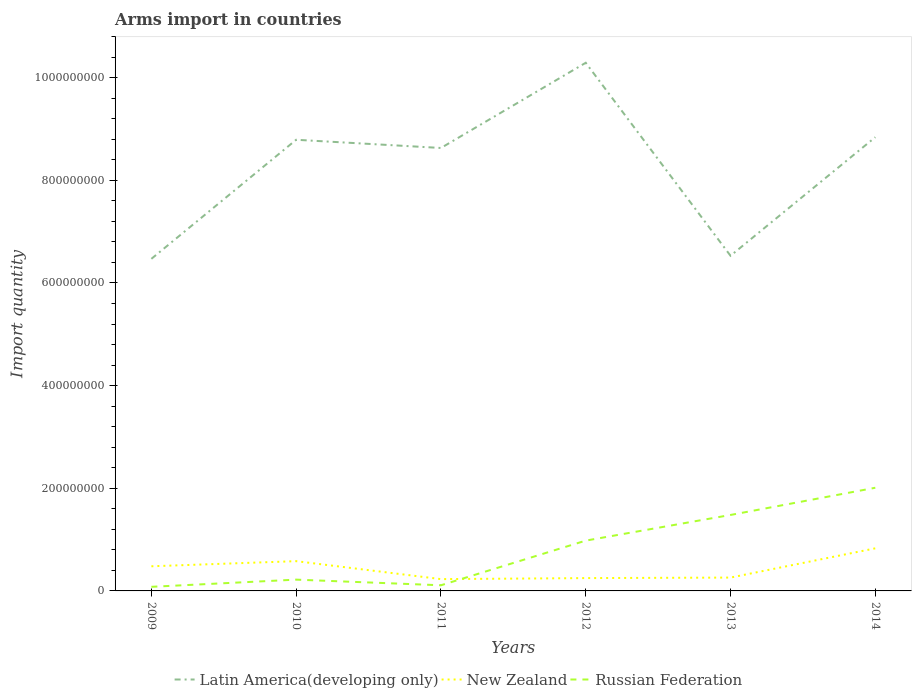How many different coloured lines are there?
Provide a succinct answer. 3. Does the line corresponding to Russian Federation intersect with the line corresponding to New Zealand?
Give a very brief answer. Yes. Across all years, what is the maximum total arms import in Russian Federation?
Offer a very short reply. 8.00e+06. What is the total total arms import in Russian Federation in the graph?
Offer a very short reply. -7.60e+07. What is the difference between the highest and the second highest total arms import in New Zealand?
Offer a terse response. 6.00e+07. How many lines are there?
Keep it short and to the point. 3. How many years are there in the graph?
Your response must be concise. 6. What is the difference between two consecutive major ticks on the Y-axis?
Your answer should be very brief. 2.00e+08. Are the values on the major ticks of Y-axis written in scientific E-notation?
Provide a succinct answer. No. Does the graph contain any zero values?
Provide a short and direct response. No. Does the graph contain grids?
Ensure brevity in your answer.  No. Where does the legend appear in the graph?
Your answer should be very brief. Bottom center. How many legend labels are there?
Provide a succinct answer. 3. How are the legend labels stacked?
Provide a succinct answer. Horizontal. What is the title of the graph?
Ensure brevity in your answer.  Arms import in countries. Does "Panama" appear as one of the legend labels in the graph?
Offer a very short reply. No. What is the label or title of the Y-axis?
Offer a very short reply. Import quantity. What is the Import quantity of Latin America(developing only) in 2009?
Make the answer very short. 6.47e+08. What is the Import quantity of New Zealand in 2009?
Your answer should be very brief. 4.80e+07. What is the Import quantity of Russian Federation in 2009?
Make the answer very short. 8.00e+06. What is the Import quantity in Latin America(developing only) in 2010?
Offer a terse response. 8.79e+08. What is the Import quantity in New Zealand in 2010?
Make the answer very short. 5.80e+07. What is the Import quantity in Russian Federation in 2010?
Your answer should be very brief. 2.20e+07. What is the Import quantity of Latin America(developing only) in 2011?
Ensure brevity in your answer.  8.63e+08. What is the Import quantity of New Zealand in 2011?
Provide a short and direct response. 2.30e+07. What is the Import quantity of Russian Federation in 2011?
Provide a short and direct response. 1.10e+07. What is the Import quantity of Latin America(developing only) in 2012?
Provide a succinct answer. 1.03e+09. What is the Import quantity in New Zealand in 2012?
Keep it short and to the point. 2.50e+07. What is the Import quantity in Russian Federation in 2012?
Offer a terse response. 9.80e+07. What is the Import quantity of Latin America(developing only) in 2013?
Make the answer very short. 6.53e+08. What is the Import quantity of New Zealand in 2013?
Give a very brief answer. 2.60e+07. What is the Import quantity in Russian Federation in 2013?
Your response must be concise. 1.48e+08. What is the Import quantity of Latin America(developing only) in 2014?
Keep it short and to the point. 8.84e+08. What is the Import quantity of New Zealand in 2014?
Provide a succinct answer. 8.30e+07. What is the Import quantity of Russian Federation in 2014?
Give a very brief answer. 2.01e+08. Across all years, what is the maximum Import quantity in Latin America(developing only)?
Make the answer very short. 1.03e+09. Across all years, what is the maximum Import quantity of New Zealand?
Keep it short and to the point. 8.30e+07. Across all years, what is the maximum Import quantity in Russian Federation?
Your response must be concise. 2.01e+08. Across all years, what is the minimum Import quantity of Latin America(developing only)?
Make the answer very short. 6.47e+08. Across all years, what is the minimum Import quantity of New Zealand?
Ensure brevity in your answer.  2.30e+07. Across all years, what is the minimum Import quantity in Russian Federation?
Ensure brevity in your answer.  8.00e+06. What is the total Import quantity of Latin America(developing only) in the graph?
Make the answer very short. 4.96e+09. What is the total Import quantity in New Zealand in the graph?
Offer a very short reply. 2.63e+08. What is the total Import quantity in Russian Federation in the graph?
Your answer should be very brief. 4.88e+08. What is the difference between the Import quantity of Latin America(developing only) in 2009 and that in 2010?
Your answer should be very brief. -2.32e+08. What is the difference between the Import quantity in New Zealand in 2009 and that in 2010?
Your answer should be very brief. -1.00e+07. What is the difference between the Import quantity in Russian Federation in 2009 and that in 2010?
Provide a succinct answer. -1.40e+07. What is the difference between the Import quantity in Latin America(developing only) in 2009 and that in 2011?
Offer a terse response. -2.16e+08. What is the difference between the Import quantity of New Zealand in 2009 and that in 2011?
Make the answer very short. 2.50e+07. What is the difference between the Import quantity in Russian Federation in 2009 and that in 2011?
Offer a very short reply. -3.00e+06. What is the difference between the Import quantity in Latin America(developing only) in 2009 and that in 2012?
Offer a very short reply. -3.82e+08. What is the difference between the Import quantity in New Zealand in 2009 and that in 2012?
Give a very brief answer. 2.30e+07. What is the difference between the Import quantity of Russian Federation in 2009 and that in 2012?
Offer a terse response. -9.00e+07. What is the difference between the Import quantity of Latin America(developing only) in 2009 and that in 2013?
Provide a short and direct response. -6.00e+06. What is the difference between the Import quantity of New Zealand in 2009 and that in 2013?
Give a very brief answer. 2.20e+07. What is the difference between the Import quantity of Russian Federation in 2009 and that in 2013?
Your answer should be compact. -1.40e+08. What is the difference between the Import quantity of Latin America(developing only) in 2009 and that in 2014?
Offer a terse response. -2.37e+08. What is the difference between the Import quantity of New Zealand in 2009 and that in 2014?
Ensure brevity in your answer.  -3.50e+07. What is the difference between the Import quantity of Russian Federation in 2009 and that in 2014?
Keep it short and to the point. -1.93e+08. What is the difference between the Import quantity in Latin America(developing only) in 2010 and that in 2011?
Your answer should be very brief. 1.60e+07. What is the difference between the Import quantity in New Zealand in 2010 and that in 2011?
Ensure brevity in your answer.  3.50e+07. What is the difference between the Import quantity in Russian Federation in 2010 and that in 2011?
Provide a short and direct response. 1.10e+07. What is the difference between the Import quantity in Latin America(developing only) in 2010 and that in 2012?
Offer a terse response. -1.50e+08. What is the difference between the Import quantity in New Zealand in 2010 and that in 2012?
Your answer should be very brief. 3.30e+07. What is the difference between the Import quantity in Russian Federation in 2010 and that in 2012?
Offer a very short reply. -7.60e+07. What is the difference between the Import quantity in Latin America(developing only) in 2010 and that in 2013?
Keep it short and to the point. 2.26e+08. What is the difference between the Import quantity in New Zealand in 2010 and that in 2013?
Your answer should be compact. 3.20e+07. What is the difference between the Import quantity of Russian Federation in 2010 and that in 2013?
Make the answer very short. -1.26e+08. What is the difference between the Import quantity of Latin America(developing only) in 2010 and that in 2014?
Give a very brief answer. -5.00e+06. What is the difference between the Import quantity in New Zealand in 2010 and that in 2014?
Give a very brief answer. -2.50e+07. What is the difference between the Import quantity of Russian Federation in 2010 and that in 2014?
Offer a terse response. -1.79e+08. What is the difference between the Import quantity in Latin America(developing only) in 2011 and that in 2012?
Provide a short and direct response. -1.66e+08. What is the difference between the Import quantity in New Zealand in 2011 and that in 2012?
Ensure brevity in your answer.  -2.00e+06. What is the difference between the Import quantity in Russian Federation in 2011 and that in 2012?
Ensure brevity in your answer.  -8.70e+07. What is the difference between the Import quantity of Latin America(developing only) in 2011 and that in 2013?
Your answer should be very brief. 2.10e+08. What is the difference between the Import quantity in Russian Federation in 2011 and that in 2013?
Your answer should be compact. -1.37e+08. What is the difference between the Import quantity of Latin America(developing only) in 2011 and that in 2014?
Your answer should be compact. -2.10e+07. What is the difference between the Import quantity in New Zealand in 2011 and that in 2014?
Provide a short and direct response. -6.00e+07. What is the difference between the Import quantity in Russian Federation in 2011 and that in 2014?
Keep it short and to the point. -1.90e+08. What is the difference between the Import quantity in Latin America(developing only) in 2012 and that in 2013?
Give a very brief answer. 3.76e+08. What is the difference between the Import quantity in New Zealand in 2012 and that in 2013?
Ensure brevity in your answer.  -1.00e+06. What is the difference between the Import quantity in Russian Federation in 2012 and that in 2013?
Keep it short and to the point. -5.00e+07. What is the difference between the Import quantity in Latin America(developing only) in 2012 and that in 2014?
Your response must be concise. 1.45e+08. What is the difference between the Import quantity of New Zealand in 2012 and that in 2014?
Offer a terse response. -5.80e+07. What is the difference between the Import quantity in Russian Federation in 2012 and that in 2014?
Give a very brief answer. -1.03e+08. What is the difference between the Import quantity in Latin America(developing only) in 2013 and that in 2014?
Your answer should be very brief. -2.31e+08. What is the difference between the Import quantity in New Zealand in 2013 and that in 2014?
Offer a very short reply. -5.70e+07. What is the difference between the Import quantity of Russian Federation in 2013 and that in 2014?
Give a very brief answer. -5.30e+07. What is the difference between the Import quantity in Latin America(developing only) in 2009 and the Import quantity in New Zealand in 2010?
Provide a short and direct response. 5.89e+08. What is the difference between the Import quantity in Latin America(developing only) in 2009 and the Import quantity in Russian Federation in 2010?
Provide a short and direct response. 6.25e+08. What is the difference between the Import quantity in New Zealand in 2009 and the Import quantity in Russian Federation in 2010?
Provide a short and direct response. 2.60e+07. What is the difference between the Import quantity of Latin America(developing only) in 2009 and the Import quantity of New Zealand in 2011?
Keep it short and to the point. 6.24e+08. What is the difference between the Import quantity in Latin America(developing only) in 2009 and the Import quantity in Russian Federation in 2011?
Keep it short and to the point. 6.36e+08. What is the difference between the Import quantity in New Zealand in 2009 and the Import quantity in Russian Federation in 2011?
Ensure brevity in your answer.  3.70e+07. What is the difference between the Import quantity of Latin America(developing only) in 2009 and the Import quantity of New Zealand in 2012?
Provide a short and direct response. 6.22e+08. What is the difference between the Import quantity of Latin America(developing only) in 2009 and the Import quantity of Russian Federation in 2012?
Your answer should be compact. 5.49e+08. What is the difference between the Import quantity in New Zealand in 2009 and the Import quantity in Russian Federation in 2012?
Keep it short and to the point. -5.00e+07. What is the difference between the Import quantity in Latin America(developing only) in 2009 and the Import quantity in New Zealand in 2013?
Provide a succinct answer. 6.21e+08. What is the difference between the Import quantity in Latin America(developing only) in 2009 and the Import quantity in Russian Federation in 2013?
Make the answer very short. 4.99e+08. What is the difference between the Import quantity in New Zealand in 2009 and the Import quantity in Russian Federation in 2013?
Give a very brief answer. -1.00e+08. What is the difference between the Import quantity in Latin America(developing only) in 2009 and the Import quantity in New Zealand in 2014?
Keep it short and to the point. 5.64e+08. What is the difference between the Import quantity of Latin America(developing only) in 2009 and the Import quantity of Russian Federation in 2014?
Provide a short and direct response. 4.46e+08. What is the difference between the Import quantity in New Zealand in 2009 and the Import quantity in Russian Federation in 2014?
Your response must be concise. -1.53e+08. What is the difference between the Import quantity of Latin America(developing only) in 2010 and the Import quantity of New Zealand in 2011?
Offer a very short reply. 8.56e+08. What is the difference between the Import quantity of Latin America(developing only) in 2010 and the Import quantity of Russian Federation in 2011?
Offer a terse response. 8.68e+08. What is the difference between the Import quantity of New Zealand in 2010 and the Import quantity of Russian Federation in 2011?
Your answer should be compact. 4.70e+07. What is the difference between the Import quantity of Latin America(developing only) in 2010 and the Import quantity of New Zealand in 2012?
Your answer should be very brief. 8.54e+08. What is the difference between the Import quantity in Latin America(developing only) in 2010 and the Import quantity in Russian Federation in 2012?
Your answer should be very brief. 7.81e+08. What is the difference between the Import quantity in New Zealand in 2010 and the Import quantity in Russian Federation in 2012?
Your answer should be compact. -4.00e+07. What is the difference between the Import quantity of Latin America(developing only) in 2010 and the Import quantity of New Zealand in 2013?
Your answer should be very brief. 8.53e+08. What is the difference between the Import quantity of Latin America(developing only) in 2010 and the Import quantity of Russian Federation in 2013?
Give a very brief answer. 7.31e+08. What is the difference between the Import quantity in New Zealand in 2010 and the Import quantity in Russian Federation in 2013?
Provide a short and direct response. -9.00e+07. What is the difference between the Import quantity in Latin America(developing only) in 2010 and the Import quantity in New Zealand in 2014?
Provide a succinct answer. 7.96e+08. What is the difference between the Import quantity of Latin America(developing only) in 2010 and the Import quantity of Russian Federation in 2014?
Give a very brief answer. 6.78e+08. What is the difference between the Import quantity of New Zealand in 2010 and the Import quantity of Russian Federation in 2014?
Keep it short and to the point. -1.43e+08. What is the difference between the Import quantity of Latin America(developing only) in 2011 and the Import quantity of New Zealand in 2012?
Provide a succinct answer. 8.38e+08. What is the difference between the Import quantity of Latin America(developing only) in 2011 and the Import quantity of Russian Federation in 2012?
Offer a terse response. 7.65e+08. What is the difference between the Import quantity in New Zealand in 2011 and the Import quantity in Russian Federation in 2012?
Make the answer very short. -7.50e+07. What is the difference between the Import quantity in Latin America(developing only) in 2011 and the Import quantity in New Zealand in 2013?
Keep it short and to the point. 8.37e+08. What is the difference between the Import quantity in Latin America(developing only) in 2011 and the Import quantity in Russian Federation in 2013?
Keep it short and to the point. 7.15e+08. What is the difference between the Import quantity in New Zealand in 2011 and the Import quantity in Russian Federation in 2013?
Your answer should be compact. -1.25e+08. What is the difference between the Import quantity of Latin America(developing only) in 2011 and the Import quantity of New Zealand in 2014?
Your answer should be very brief. 7.80e+08. What is the difference between the Import quantity in Latin America(developing only) in 2011 and the Import quantity in Russian Federation in 2014?
Provide a succinct answer. 6.62e+08. What is the difference between the Import quantity in New Zealand in 2011 and the Import quantity in Russian Federation in 2014?
Offer a terse response. -1.78e+08. What is the difference between the Import quantity of Latin America(developing only) in 2012 and the Import quantity of New Zealand in 2013?
Ensure brevity in your answer.  1.00e+09. What is the difference between the Import quantity in Latin America(developing only) in 2012 and the Import quantity in Russian Federation in 2013?
Provide a succinct answer. 8.81e+08. What is the difference between the Import quantity of New Zealand in 2012 and the Import quantity of Russian Federation in 2013?
Offer a very short reply. -1.23e+08. What is the difference between the Import quantity of Latin America(developing only) in 2012 and the Import quantity of New Zealand in 2014?
Give a very brief answer. 9.46e+08. What is the difference between the Import quantity in Latin America(developing only) in 2012 and the Import quantity in Russian Federation in 2014?
Keep it short and to the point. 8.28e+08. What is the difference between the Import quantity of New Zealand in 2012 and the Import quantity of Russian Federation in 2014?
Provide a succinct answer. -1.76e+08. What is the difference between the Import quantity in Latin America(developing only) in 2013 and the Import quantity in New Zealand in 2014?
Your answer should be very brief. 5.70e+08. What is the difference between the Import quantity in Latin America(developing only) in 2013 and the Import quantity in Russian Federation in 2014?
Offer a terse response. 4.52e+08. What is the difference between the Import quantity in New Zealand in 2013 and the Import quantity in Russian Federation in 2014?
Ensure brevity in your answer.  -1.75e+08. What is the average Import quantity of Latin America(developing only) per year?
Give a very brief answer. 8.26e+08. What is the average Import quantity of New Zealand per year?
Your answer should be very brief. 4.38e+07. What is the average Import quantity in Russian Federation per year?
Make the answer very short. 8.13e+07. In the year 2009, what is the difference between the Import quantity in Latin America(developing only) and Import quantity in New Zealand?
Give a very brief answer. 5.99e+08. In the year 2009, what is the difference between the Import quantity of Latin America(developing only) and Import quantity of Russian Federation?
Offer a very short reply. 6.39e+08. In the year 2009, what is the difference between the Import quantity in New Zealand and Import quantity in Russian Federation?
Make the answer very short. 4.00e+07. In the year 2010, what is the difference between the Import quantity of Latin America(developing only) and Import quantity of New Zealand?
Your answer should be compact. 8.21e+08. In the year 2010, what is the difference between the Import quantity in Latin America(developing only) and Import quantity in Russian Federation?
Your answer should be compact. 8.57e+08. In the year 2010, what is the difference between the Import quantity in New Zealand and Import quantity in Russian Federation?
Offer a very short reply. 3.60e+07. In the year 2011, what is the difference between the Import quantity of Latin America(developing only) and Import quantity of New Zealand?
Keep it short and to the point. 8.40e+08. In the year 2011, what is the difference between the Import quantity of Latin America(developing only) and Import quantity of Russian Federation?
Give a very brief answer. 8.52e+08. In the year 2011, what is the difference between the Import quantity in New Zealand and Import quantity in Russian Federation?
Keep it short and to the point. 1.20e+07. In the year 2012, what is the difference between the Import quantity in Latin America(developing only) and Import quantity in New Zealand?
Give a very brief answer. 1.00e+09. In the year 2012, what is the difference between the Import quantity of Latin America(developing only) and Import quantity of Russian Federation?
Keep it short and to the point. 9.31e+08. In the year 2012, what is the difference between the Import quantity of New Zealand and Import quantity of Russian Federation?
Offer a very short reply. -7.30e+07. In the year 2013, what is the difference between the Import quantity in Latin America(developing only) and Import quantity in New Zealand?
Give a very brief answer. 6.27e+08. In the year 2013, what is the difference between the Import quantity of Latin America(developing only) and Import quantity of Russian Federation?
Make the answer very short. 5.05e+08. In the year 2013, what is the difference between the Import quantity in New Zealand and Import quantity in Russian Federation?
Give a very brief answer. -1.22e+08. In the year 2014, what is the difference between the Import quantity of Latin America(developing only) and Import quantity of New Zealand?
Your answer should be very brief. 8.01e+08. In the year 2014, what is the difference between the Import quantity of Latin America(developing only) and Import quantity of Russian Federation?
Ensure brevity in your answer.  6.83e+08. In the year 2014, what is the difference between the Import quantity in New Zealand and Import quantity in Russian Federation?
Provide a succinct answer. -1.18e+08. What is the ratio of the Import quantity in Latin America(developing only) in 2009 to that in 2010?
Your response must be concise. 0.74. What is the ratio of the Import quantity of New Zealand in 2009 to that in 2010?
Ensure brevity in your answer.  0.83. What is the ratio of the Import quantity in Russian Federation in 2009 to that in 2010?
Ensure brevity in your answer.  0.36. What is the ratio of the Import quantity of Latin America(developing only) in 2009 to that in 2011?
Your response must be concise. 0.75. What is the ratio of the Import quantity in New Zealand in 2009 to that in 2011?
Make the answer very short. 2.09. What is the ratio of the Import quantity in Russian Federation in 2009 to that in 2011?
Ensure brevity in your answer.  0.73. What is the ratio of the Import quantity in Latin America(developing only) in 2009 to that in 2012?
Provide a succinct answer. 0.63. What is the ratio of the Import quantity in New Zealand in 2009 to that in 2012?
Offer a very short reply. 1.92. What is the ratio of the Import quantity of Russian Federation in 2009 to that in 2012?
Make the answer very short. 0.08. What is the ratio of the Import quantity in Latin America(developing only) in 2009 to that in 2013?
Offer a terse response. 0.99. What is the ratio of the Import quantity of New Zealand in 2009 to that in 2013?
Make the answer very short. 1.85. What is the ratio of the Import quantity of Russian Federation in 2009 to that in 2013?
Your answer should be very brief. 0.05. What is the ratio of the Import quantity in Latin America(developing only) in 2009 to that in 2014?
Give a very brief answer. 0.73. What is the ratio of the Import quantity of New Zealand in 2009 to that in 2014?
Your answer should be very brief. 0.58. What is the ratio of the Import quantity of Russian Federation in 2009 to that in 2014?
Offer a terse response. 0.04. What is the ratio of the Import quantity of Latin America(developing only) in 2010 to that in 2011?
Ensure brevity in your answer.  1.02. What is the ratio of the Import quantity of New Zealand in 2010 to that in 2011?
Make the answer very short. 2.52. What is the ratio of the Import quantity of Russian Federation in 2010 to that in 2011?
Provide a short and direct response. 2. What is the ratio of the Import quantity in Latin America(developing only) in 2010 to that in 2012?
Ensure brevity in your answer.  0.85. What is the ratio of the Import quantity of New Zealand in 2010 to that in 2012?
Your answer should be very brief. 2.32. What is the ratio of the Import quantity of Russian Federation in 2010 to that in 2012?
Offer a terse response. 0.22. What is the ratio of the Import quantity of Latin America(developing only) in 2010 to that in 2013?
Offer a terse response. 1.35. What is the ratio of the Import quantity in New Zealand in 2010 to that in 2013?
Offer a very short reply. 2.23. What is the ratio of the Import quantity in Russian Federation in 2010 to that in 2013?
Make the answer very short. 0.15. What is the ratio of the Import quantity in New Zealand in 2010 to that in 2014?
Your answer should be very brief. 0.7. What is the ratio of the Import quantity in Russian Federation in 2010 to that in 2014?
Keep it short and to the point. 0.11. What is the ratio of the Import quantity in Latin America(developing only) in 2011 to that in 2012?
Provide a succinct answer. 0.84. What is the ratio of the Import quantity of Russian Federation in 2011 to that in 2012?
Your answer should be very brief. 0.11. What is the ratio of the Import quantity of Latin America(developing only) in 2011 to that in 2013?
Keep it short and to the point. 1.32. What is the ratio of the Import quantity in New Zealand in 2011 to that in 2013?
Your answer should be compact. 0.88. What is the ratio of the Import quantity in Russian Federation in 2011 to that in 2013?
Your answer should be very brief. 0.07. What is the ratio of the Import quantity in Latin America(developing only) in 2011 to that in 2014?
Give a very brief answer. 0.98. What is the ratio of the Import quantity of New Zealand in 2011 to that in 2014?
Provide a succinct answer. 0.28. What is the ratio of the Import quantity in Russian Federation in 2011 to that in 2014?
Offer a very short reply. 0.05. What is the ratio of the Import quantity of Latin America(developing only) in 2012 to that in 2013?
Your answer should be very brief. 1.58. What is the ratio of the Import quantity of New Zealand in 2012 to that in 2013?
Give a very brief answer. 0.96. What is the ratio of the Import quantity of Russian Federation in 2012 to that in 2013?
Your response must be concise. 0.66. What is the ratio of the Import quantity of Latin America(developing only) in 2012 to that in 2014?
Keep it short and to the point. 1.16. What is the ratio of the Import quantity in New Zealand in 2012 to that in 2014?
Offer a very short reply. 0.3. What is the ratio of the Import quantity of Russian Federation in 2012 to that in 2014?
Give a very brief answer. 0.49. What is the ratio of the Import quantity in Latin America(developing only) in 2013 to that in 2014?
Provide a succinct answer. 0.74. What is the ratio of the Import quantity in New Zealand in 2013 to that in 2014?
Keep it short and to the point. 0.31. What is the ratio of the Import quantity in Russian Federation in 2013 to that in 2014?
Keep it short and to the point. 0.74. What is the difference between the highest and the second highest Import quantity of Latin America(developing only)?
Ensure brevity in your answer.  1.45e+08. What is the difference between the highest and the second highest Import quantity in New Zealand?
Your answer should be very brief. 2.50e+07. What is the difference between the highest and the second highest Import quantity of Russian Federation?
Provide a succinct answer. 5.30e+07. What is the difference between the highest and the lowest Import quantity in Latin America(developing only)?
Offer a terse response. 3.82e+08. What is the difference between the highest and the lowest Import quantity in New Zealand?
Provide a succinct answer. 6.00e+07. What is the difference between the highest and the lowest Import quantity of Russian Federation?
Offer a terse response. 1.93e+08. 